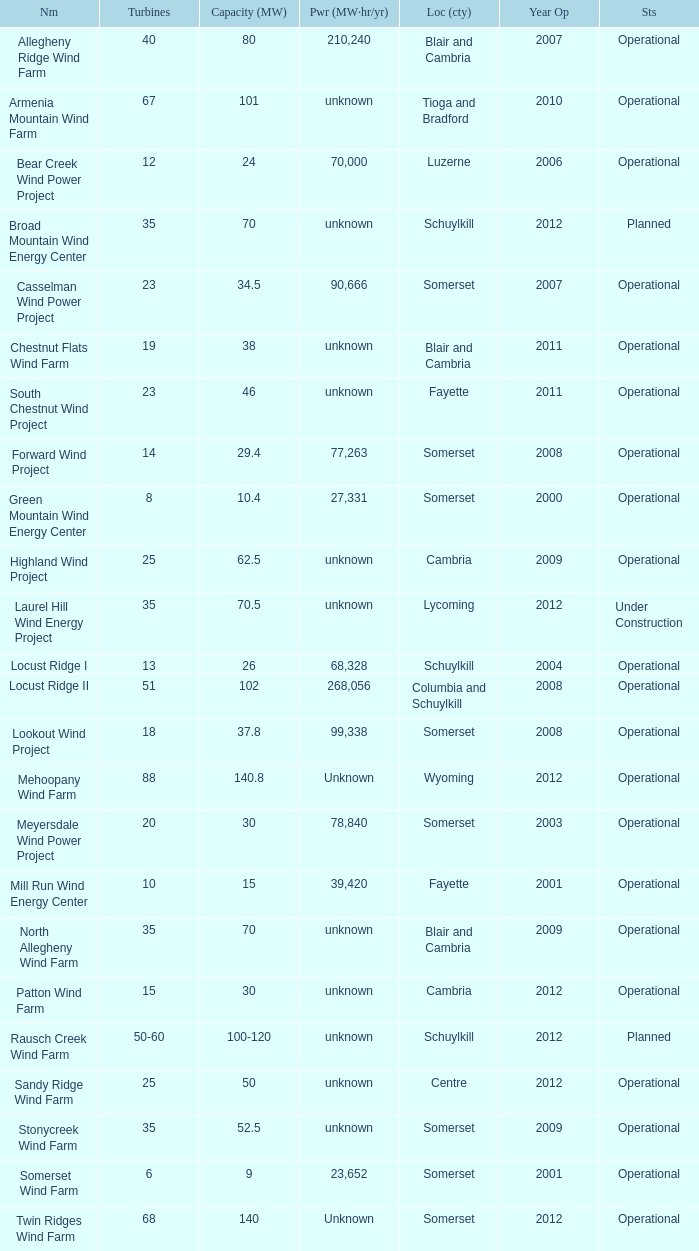What all turbines have a capacity of 30 and have a Somerset location? 20.0. 